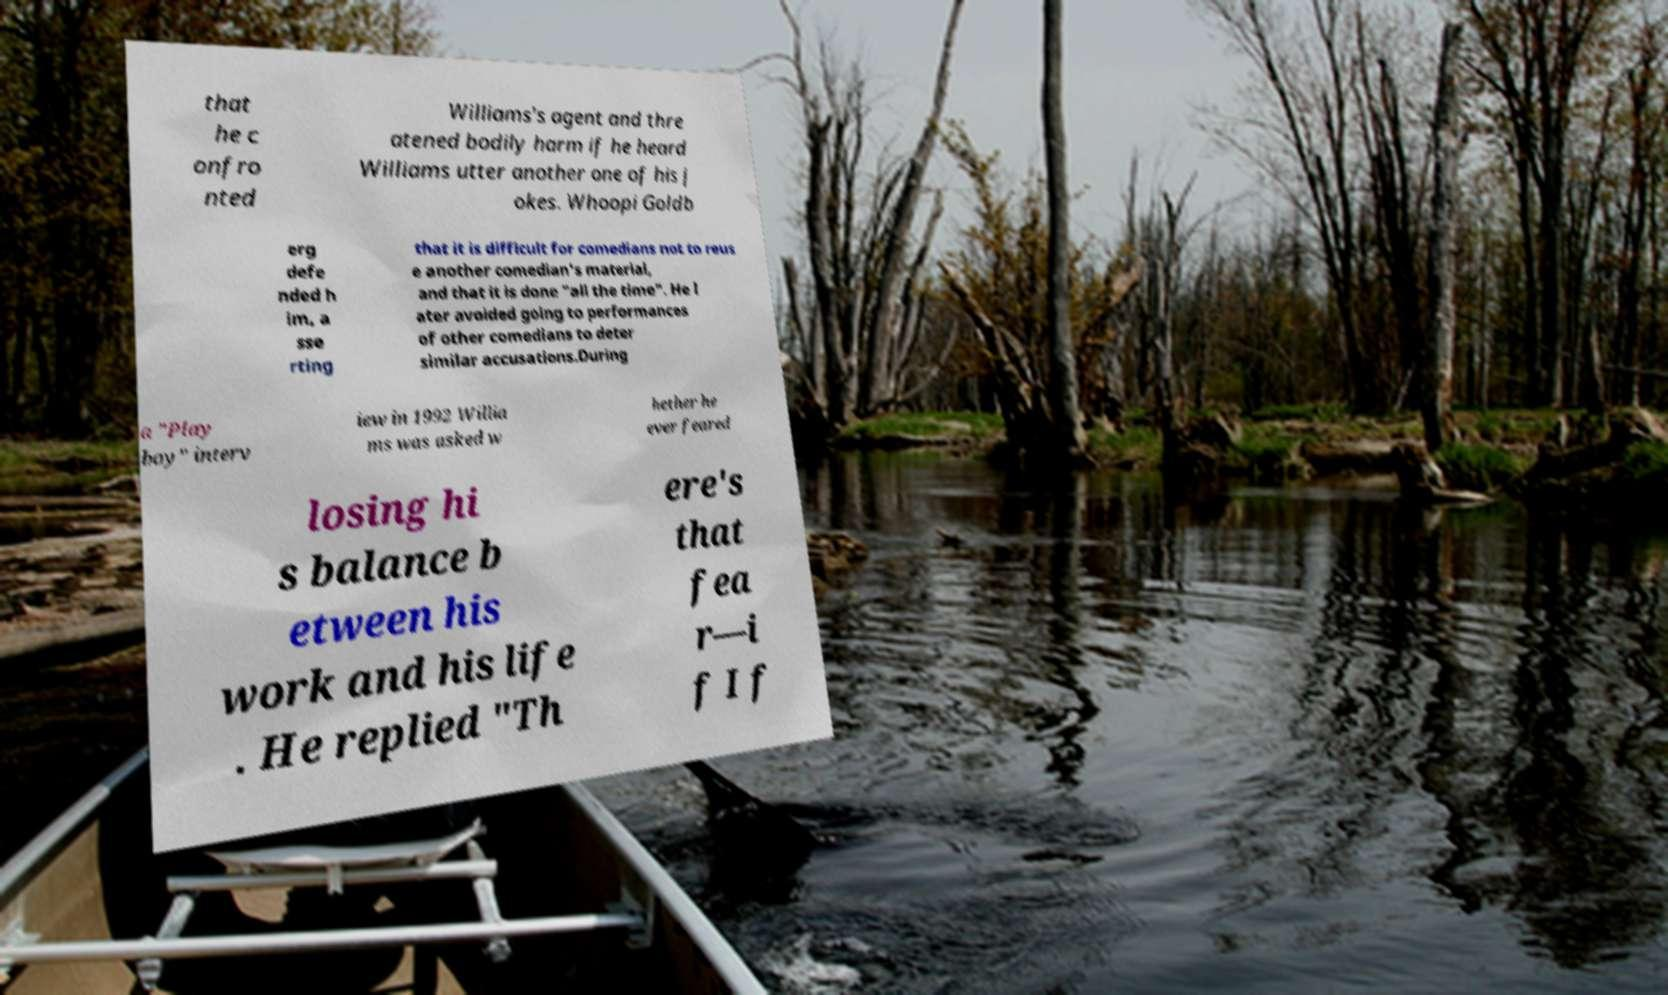Can you accurately transcribe the text from the provided image for me? that he c onfro nted Williams's agent and thre atened bodily harm if he heard Williams utter another one of his j okes. Whoopi Goldb erg defe nded h im, a sse rting that it is difficult for comedians not to reus e another comedian's material, and that it is done "all the time". He l ater avoided going to performances of other comedians to deter similar accusations.During a "Play boy" interv iew in 1992 Willia ms was asked w hether he ever feared losing hi s balance b etween his work and his life . He replied "Th ere's that fea r—i f I f 